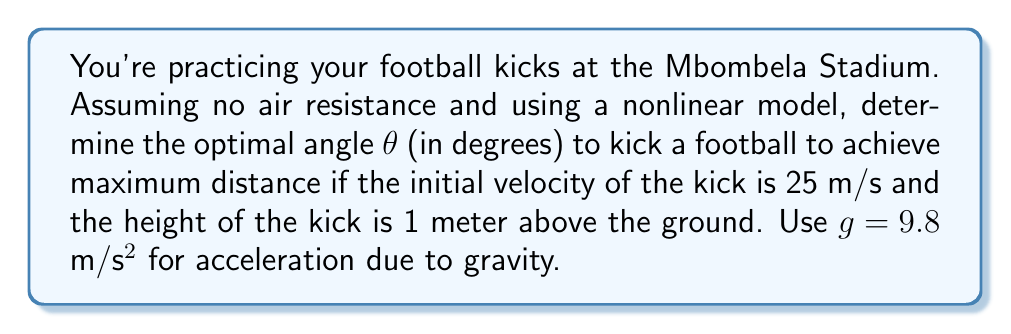Solve this math problem. To solve this problem, we'll use the equations of projectile motion and optimize for maximum range.

Step 1: Set up the equations of motion
The horizontal and vertical components of motion are given by:
$$x(t) = v_0 \cos(\theta) t$$
$$y(t) = h_0 + v_0 \sin(\theta) t - \frac{1}{2}gt^2$$

Where:
$v_0 = 25$ m/s (initial velocity)
$h_0 = 1$ m (initial height)
$g = 9.8$ m/s² (acceleration due to gravity)

Step 2: Determine the time of flight
The ball reaches the ground when $y(t) = 0$. Solving this equation:

$$0 = 1 + 25 \sin(\theta) t - 4.9t^2$$

This is a quadratic equation in $t$. The positive root gives the time of flight:

$$t = \frac{25 \sin(\theta) + \sqrt{625 \sin^2(\theta) + 19.6}}{9.8}$$

Step 3: Express the range in terms of θ
The range $R$ is given by $x(t)$ when the ball hits the ground:

$$R = 25 \cos(\theta) \cdot \frac{25 \sin(\theta) + \sqrt{625 \sin^2(\theta) + 19.6}}{9.8}$$

Step 4: Optimize the range
To find the maximum range, we need to differentiate $R$ with respect to θ and set it to zero. This leads to a complex nonlinear equation. Due to the complexity, we can solve this numerically.

Step 5: Numerical solution
Using numerical methods (e.g., Newton-Raphson method), we can find that the optimal angle is approximately 44.4°.

This angle is slightly less than 45° (which would be optimal for a kick from ground level) due to the initial height of 1 meter.
Answer: 44.4° 